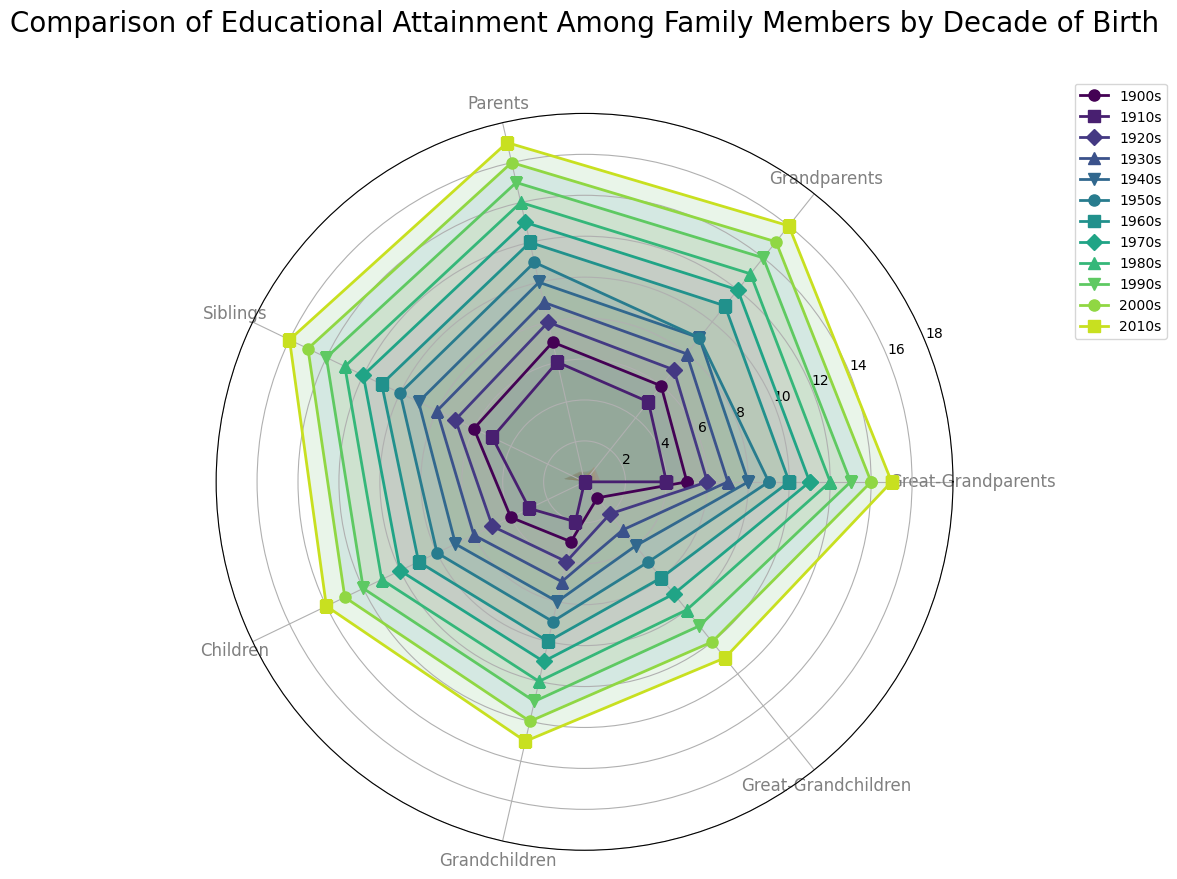What decade had the highest educational attainment among grandchildren? To determine the decade with the highest educational attainment among grandchildren, locate the line corresponding to the "Grandchildren" category and identify the decade line that reaches the highest point on this axis.
Answer: 2010s Compare the educational attainment of parents and siblings in the 1960s. Which group had higher attainment? Locate the decade line for the 1960s and compare the points for the "Parents" and "Siblings" categories. The parent's point is at 12, and the sibling's point is at 11, indicating parents had higher attainment.
Answer: Parents Which decade shows the smallest educational attainment among great-grandchildren? Locate the axis for "Great-Grandchildren" and identify the decade line that reaches the lowest point. The line for the 1910s hits the lowest value, which is 0.
Answer: 1910s Is there a general trend in educational attainment over the decades? Look at the chart's overall pattern: each decade line starts lower on the left and gradually gets higher moving right towards the later decades. This demonstrates a general increasing trend in educational attainment over the decades.
Answer: Increasing trend Calculate the total educational attainment of siblings over the entire period and find the average. Sum the educational attainment values for siblings across all decades (6+5+7+8+9+10+11+12+13+14+15+16 = 126), then divide by the number of decades (12).
Answer: 10.5 Between the 1940s and 1960s, which decade had higher educational attainment for children? Compare the points on the "Children" axis for the 1940s and 1960s. The 1940s has a value of 7, while the 1960s has a value of 9, making the 1960s higher.
Answer: 1960s Which decade had an equal educational attainment of grandparents and siblings? Locate the points where the "Grandparents" and "Siblings" lines intersect at the same height. The educational attainments are equal in the 1950s, both reaching 9.
Answer: 1950s Compute the difference between educational attainment of great-grandparents in the 1900s and the 2000s. Subtract the value for great-grandparents in the 1900s from the value in the 2000s (14-5).
Answer: 9 Which decade had the closest educational attainment values between great-grandparents and grandchildren? Identify the decades where the lines for great-grandparents and grandchildren are closest in height. In the 1900s, the great-grandparents' value is 5 and grandchildren's value is 3, making the smallest difference of 2.
Answer: 1900s 